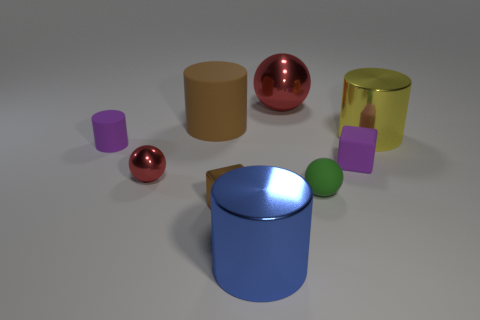Is there any other thing that is the same size as the brown cylinder?
Offer a terse response. Yes. How many other things are there of the same color as the large metallic ball?
Your answer should be very brief. 1. Are there fewer yellow cylinders that are in front of the small red thing than purple cylinders that are to the right of the large brown rubber cylinder?
Provide a succinct answer. No. Are there any tiny things behind the purple cylinder?
Your response must be concise. No. How many objects are either purple things that are to the left of the tiny metal block or large metal cylinders that are in front of the purple cylinder?
Your answer should be very brief. 2. What number of blocks are the same color as the small matte cylinder?
Provide a succinct answer. 1. What color is the small matte object that is the same shape as the tiny red metallic object?
Your answer should be very brief. Green. What shape is the large object that is on the right side of the big rubber thing and behind the big yellow metallic cylinder?
Make the answer very short. Sphere. Is the number of cylinders greater than the number of red metal balls?
Make the answer very short. Yes. What is the big blue cylinder made of?
Offer a very short reply. Metal. 